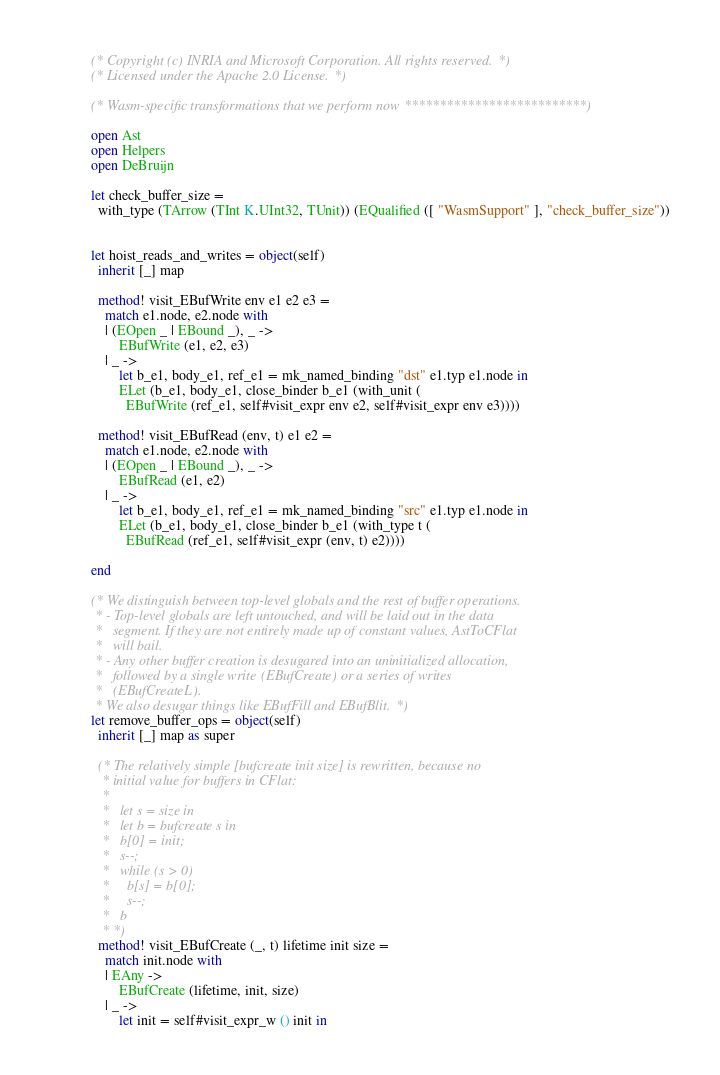Convert code to text. <code><loc_0><loc_0><loc_500><loc_500><_OCaml_>(* Copyright (c) INRIA and Microsoft Corporation. All rights reserved. *)
(* Licensed under the Apache 2.0 License. *)

(* Wasm-specific transformations that we perform now **************************)

open Ast
open Helpers
open DeBruijn

let check_buffer_size =
  with_type (TArrow (TInt K.UInt32, TUnit)) (EQualified ([ "WasmSupport" ], "check_buffer_size"))


let hoist_reads_and_writes = object(self)
  inherit [_] map

  method! visit_EBufWrite env e1 e2 e3 =
    match e1.node, e2.node with
    | (EOpen _ | EBound _), _ ->
        EBufWrite (e1, e2, e3)
    | _ ->
        let b_e1, body_e1, ref_e1 = mk_named_binding "dst" e1.typ e1.node in
        ELet (b_e1, body_e1, close_binder b_e1 (with_unit (
          EBufWrite (ref_e1, self#visit_expr env e2, self#visit_expr env e3))))

  method! visit_EBufRead (env, t) e1 e2 =
    match e1.node, e2.node with
    | (EOpen _ | EBound _), _ ->
        EBufRead (e1, e2)
    | _ ->
        let b_e1, body_e1, ref_e1 = mk_named_binding "src" e1.typ e1.node in
        ELet (b_e1, body_e1, close_binder b_e1 (with_type t (
          EBufRead (ref_e1, self#visit_expr (env, t) e2))))

end

(* We distinguish between top-level globals and the rest of buffer operations.
 * - Top-level globals are left untouched, and will be laid out in the data
 *   segment. If they are not entirely made up of constant values, AstToCFlat
 *   will bail.
 * - Any other buffer creation is desugared into an uninitialized allocation,
 *   followed by a single write (EBufCreate) or a series of writes
 *   (EBufCreateL).
 * We also desugar things like EBufFill and EBufBlit. *)
let remove_buffer_ops = object(self)
  inherit [_] map as super

  (* The relatively simple [bufcreate init size] is rewritten, because no
   * initial value for buffers in CFlat:
   *
   *   let s = size in
   *   let b = bufcreate s in
   *   b[0] = init;
   *   s--;
   *   while (s > 0)
   *     b[s] = b[0];
   *     s--;
   *   b
   * *)
  method! visit_EBufCreate (_, t) lifetime init size =
    match init.node with
    | EAny ->
        EBufCreate (lifetime, init, size)
    | _ ->
        let init = self#visit_expr_w () init in</code> 